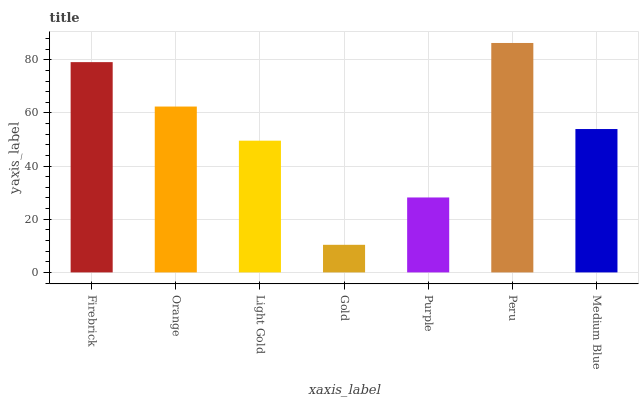Is Gold the minimum?
Answer yes or no. Yes. Is Peru the maximum?
Answer yes or no. Yes. Is Orange the minimum?
Answer yes or no. No. Is Orange the maximum?
Answer yes or no. No. Is Firebrick greater than Orange?
Answer yes or no. Yes. Is Orange less than Firebrick?
Answer yes or no. Yes. Is Orange greater than Firebrick?
Answer yes or no. No. Is Firebrick less than Orange?
Answer yes or no. No. Is Medium Blue the high median?
Answer yes or no. Yes. Is Medium Blue the low median?
Answer yes or no. Yes. Is Orange the high median?
Answer yes or no. No. Is Peru the low median?
Answer yes or no. No. 